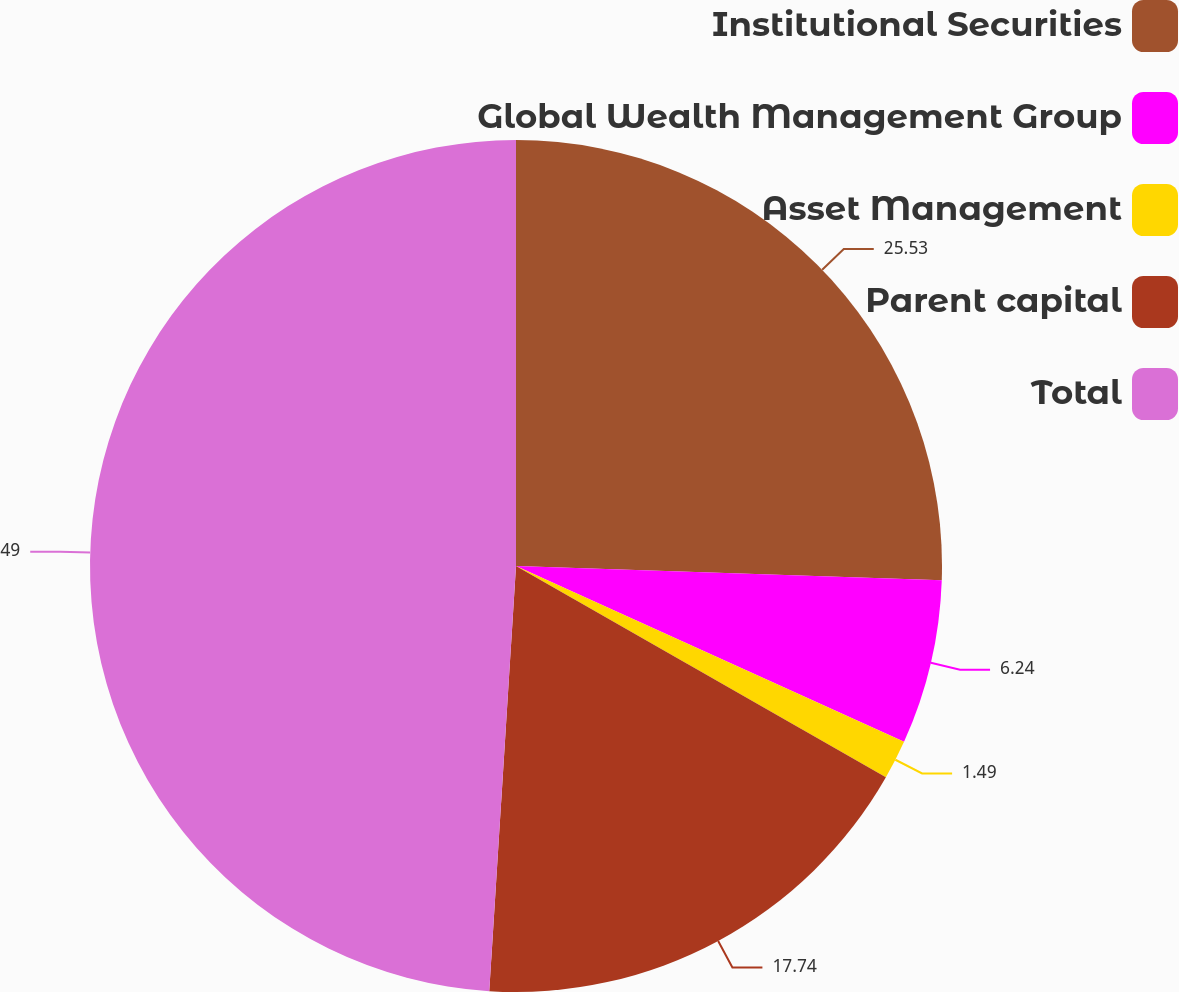<chart> <loc_0><loc_0><loc_500><loc_500><pie_chart><fcel>Institutional Securities<fcel>Global Wealth Management Group<fcel>Asset Management<fcel>Parent capital<fcel>Total<nl><fcel>25.53%<fcel>6.24%<fcel>1.49%<fcel>17.74%<fcel>49.0%<nl></chart> 